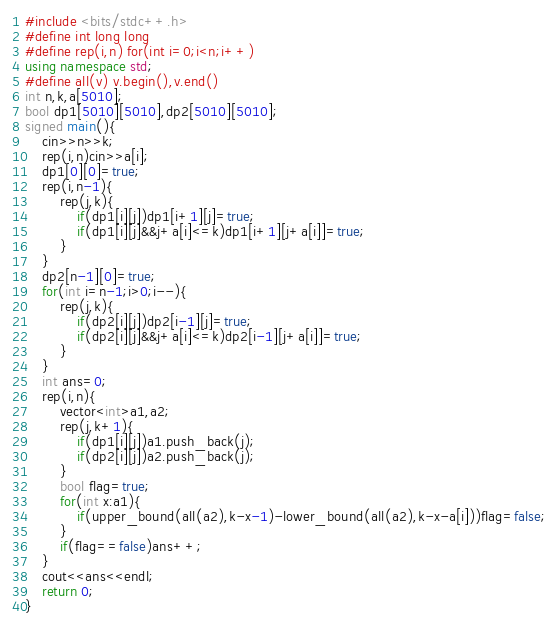Convert code to text. <code><loc_0><loc_0><loc_500><loc_500><_C++_>#include <bits/stdc++.h>
#define int long long
#define rep(i,n) for(int i=0;i<n;i++)
using namespace std;
#define all(v) v.begin(),v.end()
int n,k,a[5010];
bool dp1[5010][5010],dp2[5010][5010];
signed main(){
	cin>>n>>k;
	rep(i,n)cin>>a[i];
	dp1[0][0]=true;
	rep(i,n-1){
		rep(j,k){
			if(dp1[i][j])dp1[i+1][j]=true;
			if(dp1[i][j]&&j+a[i]<=k)dp1[i+1][j+a[i]]=true;
		}
	}
	dp2[n-1][0]=true;
	for(int i=n-1;i>0;i--){
		rep(j,k){
			if(dp2[i][j])dp2[i-1][j]=true;
			if(dp2[i][j]&&j+a[i]<=k)dp2[i-1][j+a[i]]=true;
		}
	}
	int ans=0;
	rep(i,n){
		vector<int>a1,a2;
		rep(j,k+1){
			if(dp1[i][j])a1.push_back(j);
			if(dp2[i][j])a2.push_back(j);
		}
		bool flag=true;
		for(int x:a1){
			if(upper_bound(all(a2),k-x-1)-lower_bound(all(a2),k-x-a[i]))flag=false;
		}
		if(flag==false)ans++;
	}
	cout<<ans<<endl;
	return 0;
}
</code> 